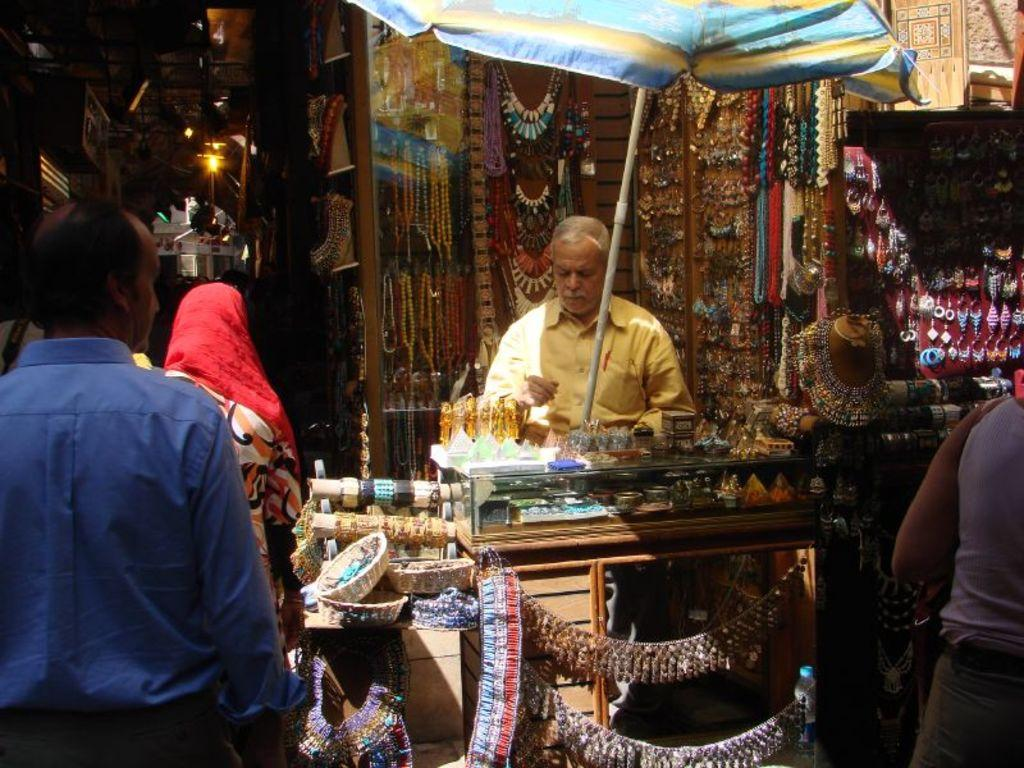What type of stores can be seen in the image? There are jewelry stores in the image. What are the people in the image doing? There are persons standing on the ground in the image. What objects are present to provide shade in the image? Parasols are visible in the image. What rhythm is the alarm playing in the image? There is no alarm present in the image, so it is not possible to determine the rhythm of any alarm. 